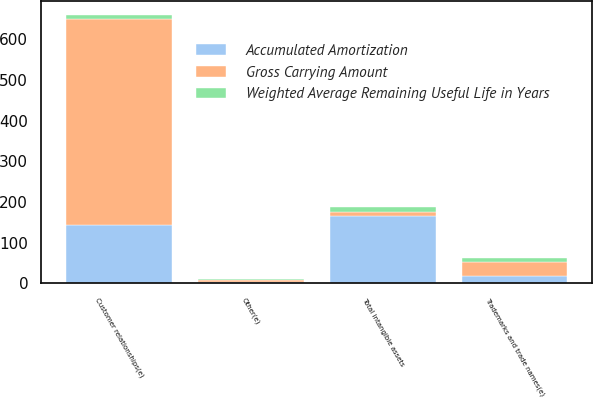Convert chart. <chart><loc_0><loc_0><loc_500><loc_500><stacked_bar_chart><ecel><fcel>Customer relationships(e)<fcel>Trademarks and trade names(e)<fcel>Other(e)<fcel>Total intangible assets<nl><fcel>Weighted Average Remaining Useful Life in Years<fcel>10.9<fcel>10.1<fcel>3<fcel>10.8<nl><fcel>Gross Carrying Amount<fcel>504.6<fcel>34.8<fcel>4.4<fcel>10.9<nl><fcel>Accumulated Amortization<fcel>144.5<fcel>18.3<fcel>2.7<fcel>165.5<nl></chart> 